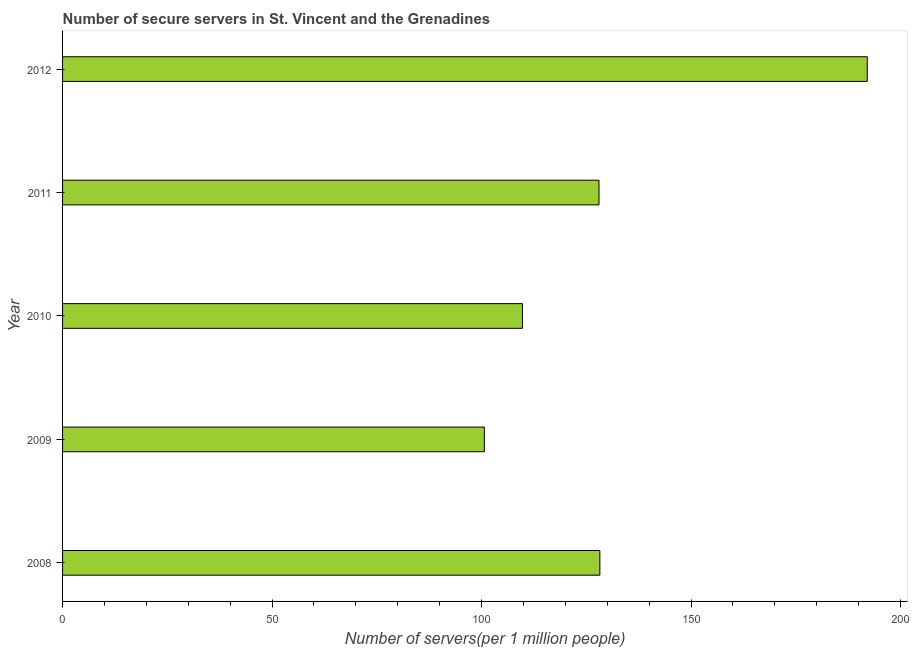What is the title of the graph?
Ensure brevity in your answer.  Number of secure servers in St. Vincent and the Grenadines. What is the label or title of the X-axis?
Your response must be concise. Number of servers(per 1 million people). What is the number of secure internet servers in 2008?
Your response must be concise. 128.25. Across all years, what is the maximum number of secure internet servers?
Your answer should be compact. 192.07. Across all years, what is the minimum number of secure internet servers?
Provide a succinct answer. 100.68. In which year was the number of secure internet servers maximum?
Give a very brief answer. 2012. What is the sum of the number of secure internet servers?
Make the answer very short. 658.81. What is the difference between the number of secure internet servers in 2009 and 2010?
Provide a succinct answer. -9.09. What is the average number of secure internet servers per year?
Provide a succinct answer. 131.76. What is the median number of secure internet servers?
Make the answer very short. 128.04. In how many years, is the number of secure internet servers greater than 180 ?
Give a very brief answer. 1. What is the ratio of the number of secure internet servers in 2010 to that in 2012?
Make the answer very short. 0.57. Is the number of secure internet servers in 2009 less than that in 2011?
Give a very brief answer. Yes. What is the difference between the highest and the second highest number of secure internet servers?
Ensure brevity in your answer.  63.83. What is the difference between the highest and the lowest number of secure internet servers?
Provide a short and direct response. 91.39. In how many years, is the number of secure internet servers greater than the average number of secure internet servers taken over all years?
Keep it short and to the point. 1. Are all the bars in the graph horizontal?
Offer a very short reply. Yes. How many years are there in the graph?
Make the answer very short. 5. Are the values on the major ticks of X-axis written in scientific E-notation?
Make the answer very short. No. What is the Number of servers(per 1 million people) of 2008?
Provide a short and direct response. 128.25. What is the Number of servers(per 1 million people) in 2009?
Give a very brief answer. 100.68. What is the Number of servers(per 1 million people) of 2010?
Your response must be concise. 109.77. What is the Number of servers(per 1 million people) of 2011?
Make the answer very short. 128.04. What is the Number of servers(per 1 million people) in 2012?
Make the answer very short. 192.07. What is the difference between the Number of servers(per 1 million people) in 2008 and 2009?
Provide a succinct answer. 27.56. What is the difference between the Number of servers(per 1 million people) in 2008 and 2010?
Ensure brevity in your answer.  18.47. What is the difference between the Number of servers(per 1 million people) in 2008 and 2011?
Your answer should be very brief. 0.21. What is the difference between the Number of servers(per 1 million people) in 2008 and 2012?
Provide a short and direct response. -63.83. What is the difference between the Number of servers(per 1 million people) in 2009 and 2010?
Your answer should be compact. -9.09. What is the difference between the Number of servers(per 1 million people) in 2009 and 2011?
Provide a succinct answer. -27.36. What is the difference between the Number of servers(per 1 million people) in 2009 and 2012?
Keep it short and to the point. -91.39. What is the difference between the Number of servers(per 1 million people) in 2010 and 2011?
Provide a succinct answer. -18.27. What is the difference between the Number of servers(per 1 million people) in 2010 and 2012?
Make the answer very short. -82.3. What is the difference between the Number of servers(per 1 million people) in 2011 and 2012?
Your answer should be compact. -64.03. What is the ratio of the Number of servers(per 1 million people) in 2008 to that in 2009?
Your response must be concise. 1.27. What is the ratio of the Number of servers(per 1 million people) in 2008 to that in 2010?
Keep it short and to the point. 1.17. What is the ratio of the Number of servers(per 1 million people) in 2008 to that in 2012?
Give a very brief answer. 0.67. What is the ratio of the Number of servers(per 1 million people) in 2009 to that in 2010?
Ensure brevity in your answer.  0.92. What is the ratio of the Number of servers(per 1 million people) in 2009 to that in 2011?
Your response must be concise. 0.79. What is the ratio of the Number of servers(per 1 million people) in 2009 to that in 2012?
Ensure brevity in your answer.  0.52. What is the ratio of the Number of servers(per 1 million people) in 2010 to that in 2011?
Your answer should be compact. 0.86. What is the ratio of the Number of servers(per 1 million people) in 2010 to that in 2012?
Ensure brevity in your answer.  0.57. What is the ratio of the Number of servers(per 1 million people) in 2011 to that in 2012?
Keep it short and to the point. 0.67. 